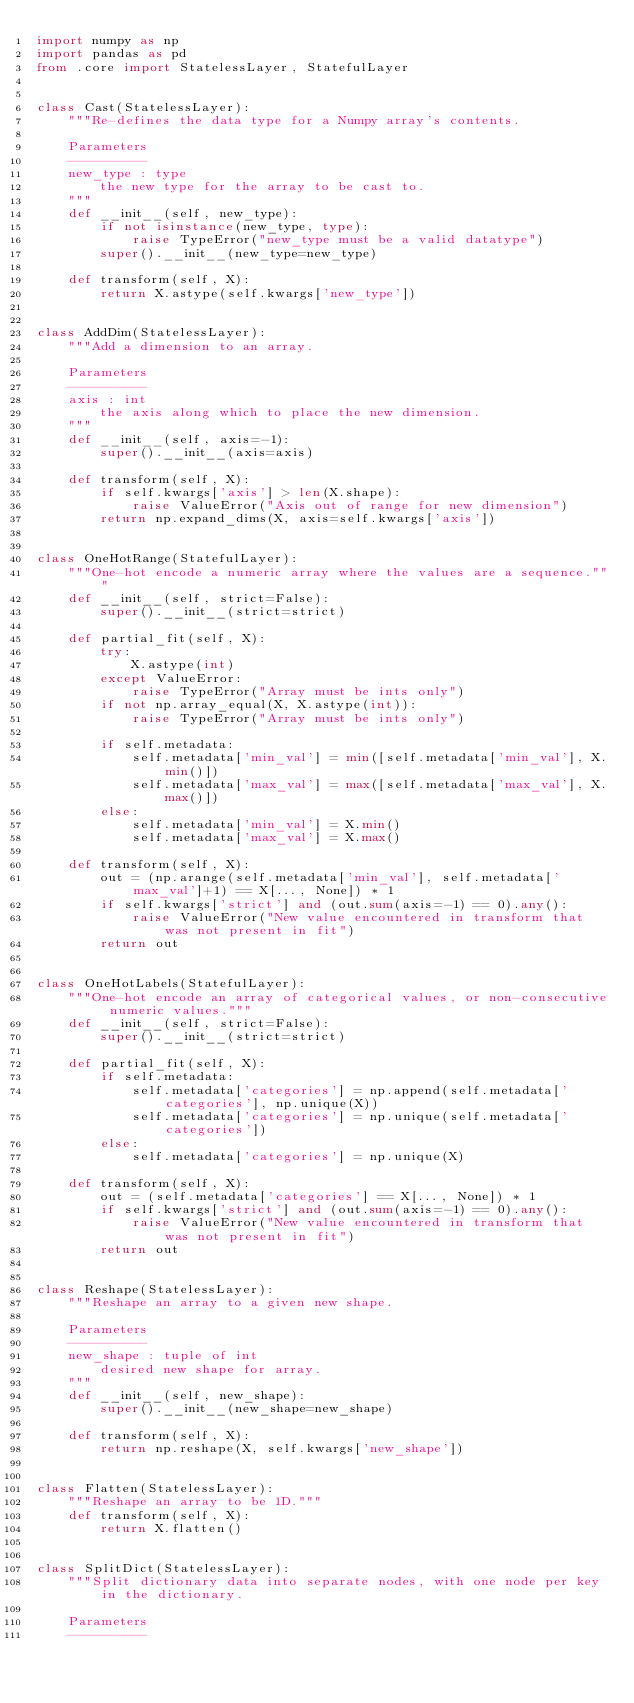<code> <loc_0><loc_0><loc_500><loc_500><_Python_>import numpy as np
import pandas as pd
from .core import StatelessLayer, StatefulLayer


class Cast(StatelessLayer):
    """Re-defines the data type for a Numpy array's contents.

    Parameters
    ----------
    new_type : type
        the new type for the array to be cast to.
    """
    def __init__(self, new_type):
        if not isinstance(new_type, type):
            raise TypeError("new_type must be a valid datatype")
        super().__init__(new_type=new_type)

    def transform(self, X):
        return X.astype(self.kwargs['new_type'])


class AddDim(StatelessLayer):
    """Add a dimension to an array.

    Parameters
    ----------
    axis : int
        the axis along which to place the new dimension.
    """
    def __init__(self, axis=-1):
        super().__init__(axis=axis)

    def transform(self, X):
        if self.kwargs['axis'] > len(X.shape):
            raise ValueError("Axis out of range for new dimension")
        return np.expand_dims(X, axis=self.kwargs['axis'])


class OneHotRange(StatefulLayer):
    """One-hot encode a numeric array where the values are a sequence."""
    def __init__(self, strict=False):
        super().__init__(strict=strict)

    def partial_fit(self, X):
        try:
            X.astype(int)
        except ValueError:
            raise TypeError("Array must be ints only")
        if not np.array_equal(X, X.astype(int)):
            raise TypeError("Array must be ints only")

        if self.metadata:
            self.metadata['min_val'] = min([self.metadata['min_val'], X.min()])
            self.metadata['max_val'] = max([self.metadata['max_val'], X.max()])
        else:
            self.metadata['min_val'] = X.min()
            self.metadata['max_val'] = X.max()

    def transform(self, X):
        out = (np.arange(self.metadata['min_val'], self.metadata['max_val']+1) == X[..., None]) * 1
        if self.kwargs['strict'] and (out.sum(axis=-1) == 0).any():
            raise ValueError("New value encountered in transform that was not present in fit")
        return out


class OneHotLabels(StatefulLayer):
    """One-hot encode an array of categorical values, or non-consecutive numeric values."""
    def __init__(self, strict=False):
        super().__init__(strict=strict)

    def partial_fit(self, X):
        if self.metadata:
            self.metadata['categories'] = np.append(self.metadata['categories'], np.unique(X))
            self.metadata['categories'] = np.unique(self.metadata['categories'])
        else:
            self.metadata['categories'] = np.unique(X)

    def transform(self, X):
        out = (self.metadata['categories'] == X[..., None]) * 1
        if self.kwargs['strict'] and (out.sum(axis=-1) == 0).any():
            raise ValueError("New value encountered in transform that was not present in fit")
        return out


class Reshape(StatelessLayer):
    """Reshape an array to a given new shape.

    Parameters
    ----------
    new_shape : tuple of int
        desired new shape for array.
    """
    def __init__(self, new_shape):
        super().__init__(new_shape=new_shape)

    def transform(self, X):
        return np.reshape(X, self.kwargs['new_shape'])


class Flatten(StatelessLayer):
    """Reshape an array to be 1D."""
    def transform(self, X):
        return X.flatten()


class SplitDict(StatelessLayer):
    """Split dictionary data into separate nodes, with one node per key in the dictionary.

    Parameters
    ----------</code> 